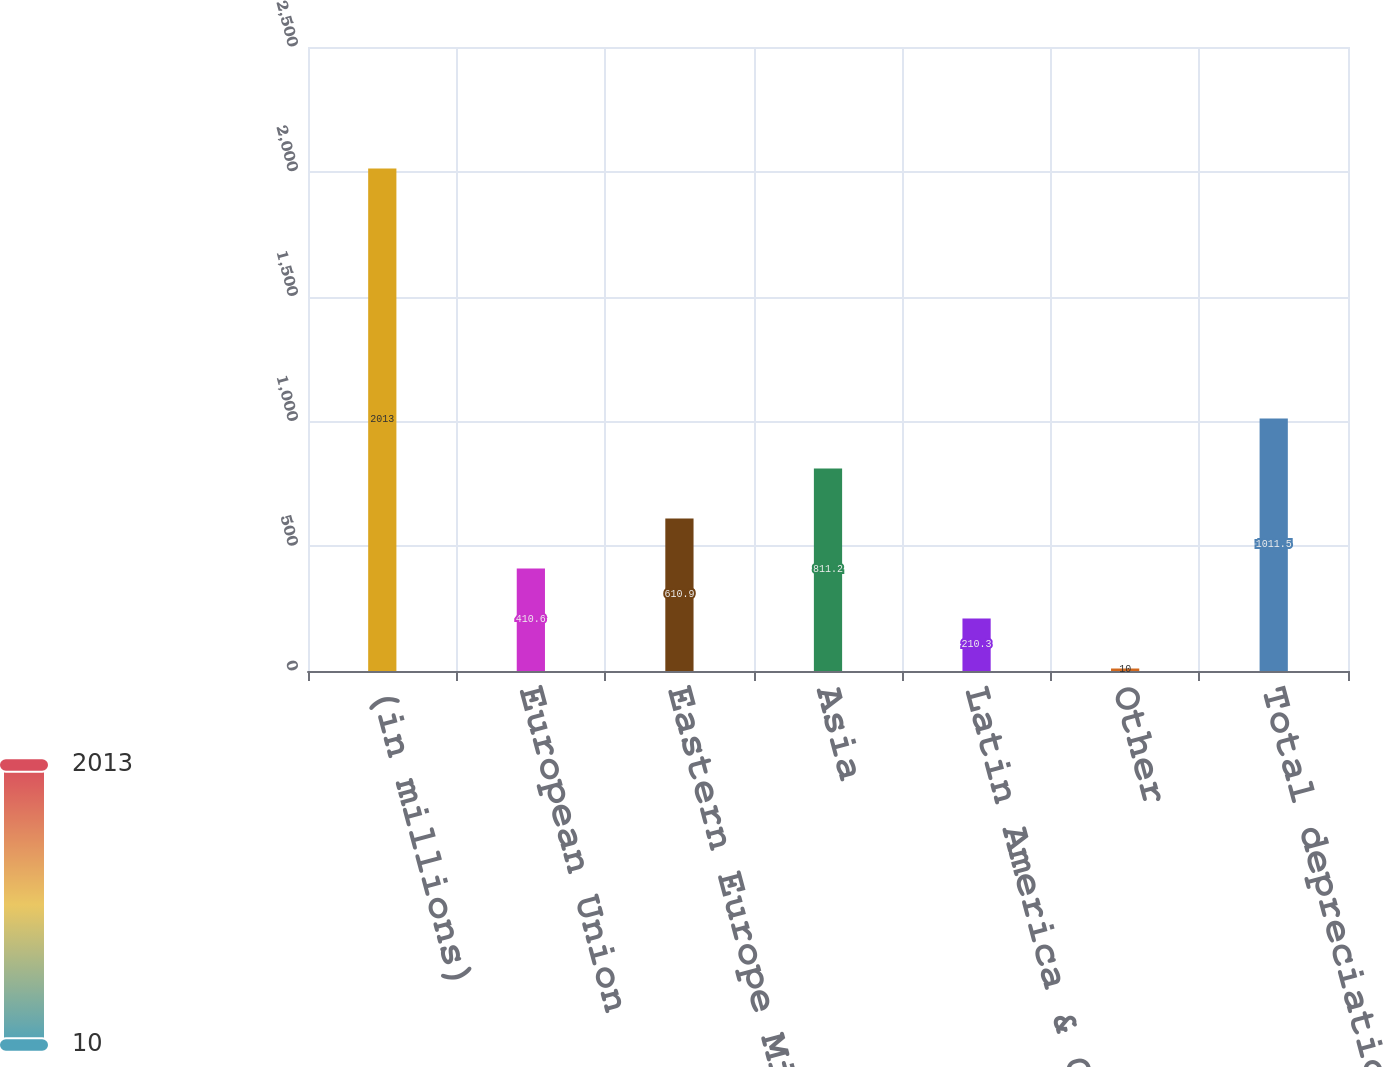Convert chart to OTSL. <chart><loc_0><loc_0><loc_500><loc_500><bar_chart><fcel>(in millions)<fcel>European Union<fcel>Eastern Europe Middle East &<fcel>Asia<fcel>Latin America & Canada<fcel>Other<fcel>Total depreciation expense<nl><fcel>2013<fcel>410.6<fcel>610.9<fcel>811.2<fcel>210.3<fcel>10<fcel>1011.5<nl></chart> 